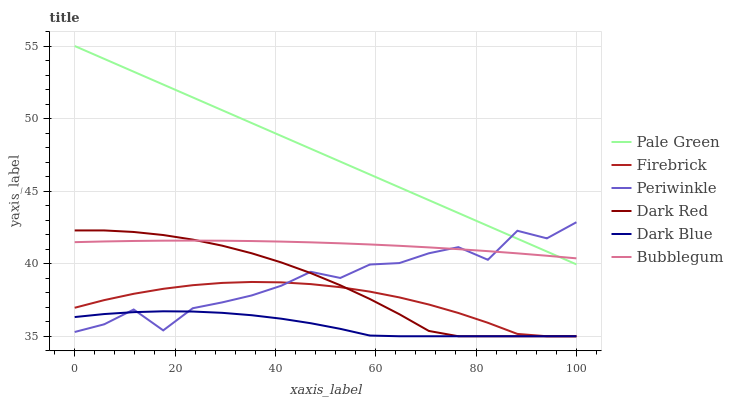Does Dark Blue have the minimum area under the curve?
Answer yes or no. Yes. Does Pale Green have the maximum area under the curve?
Answer yes or no. Yes. Does Firebrick have the minimum area under the curve?
Answer yes or no. No. Does Firebrick have the maximum area under the curve?
Answer yes or no. No. Is Pale Green the smoothest?
Answer yes or no. Yes. Is Periwinkle the roughest?
Answer yes or no. Yes. Is Firebrick the smoothest?
Answer yes or no. No. Is Firebrick the roughest?
Answer yes or no. No. Does Bubblegum have the lowest value?
Answer yes or no. No. Does Pale Green have the highest value?
Answer yes or no. Yes. Does Firebrick have the highest value?
Answer yes or no. No. Is Firebrick less than Bubblegum?
Answer yes or no. Yes. Is Bubblegum greater than Dark Blue?
Answer yes or no. Yes. Does Periwinkle intersect Pale Green?
Answer yes or no. Yes. Is Periwinkle less than Pale Green?
Answer yes or no. No. Is Periwinkle greater than Pale Green?
Answer yes or no. No. Does Firebrick intersect Bubblegum?
Answer yes or no. No. 